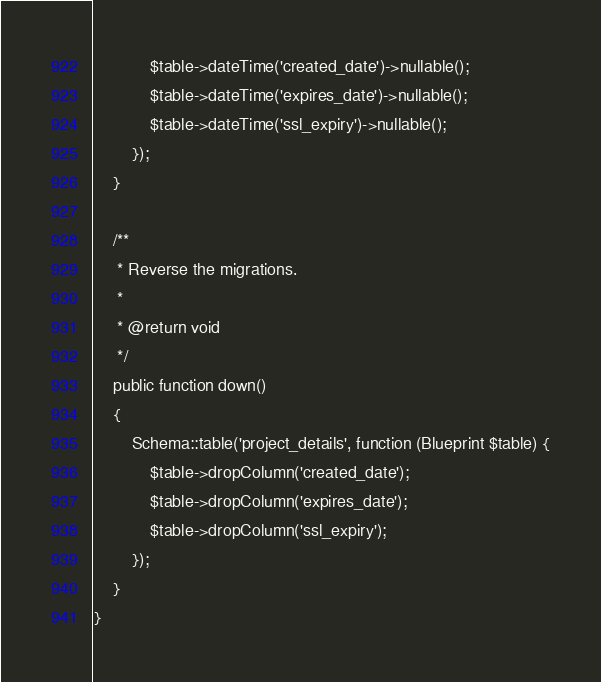<code> <loc_0><loc_0><loc_500><loc_500><_PHP_>            $table->dateTime('created_date')->nullable();
            $table->dateTime('expires_date')->nullable();
            $table->dateTime('ssl_expiry')->nullable();
        });
    }

    /**
     * Reverse the migrations.
     *
     * @return void
     */
    public function down()
    {
        Schema::table('project_details', function (Blueprint $table) {
            $table->dropColumn('created_date');
            $table->dropColumn('expires_date');
            $table->dropColumn('ssl_expiry');
        });
    }
}
</code> 